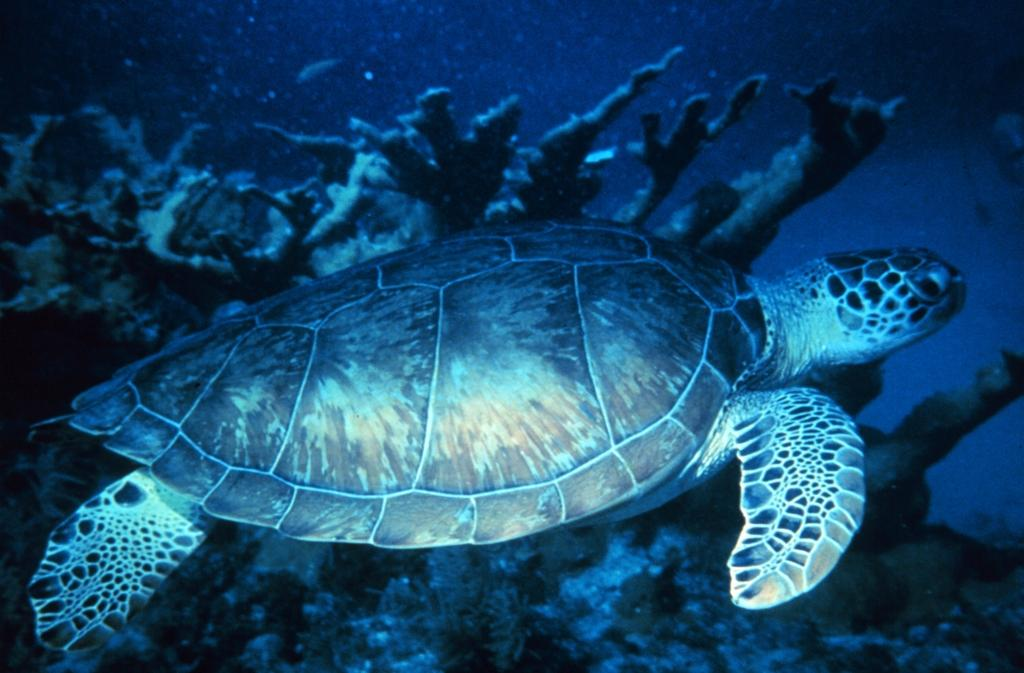What animal is present in the image? There is a tortoise in the image. What is the tortoise doing in the image? The tortoise is swimming in the water. What type of environment is depicted in the image? There are aquatic plants visible in the image, suggesting a water-based environment. What type of respect does the tortoise show to its dad in the image? There is no indication of a relationship between the tortoise and a "dad" in the image, as it only features a tortoise swimming in the water. 